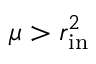Convert formula to latex. <formula><loc_0><loc_0><loc_500><loc_500>\mu > r _ { i n } ^ { 2 }</formula> 